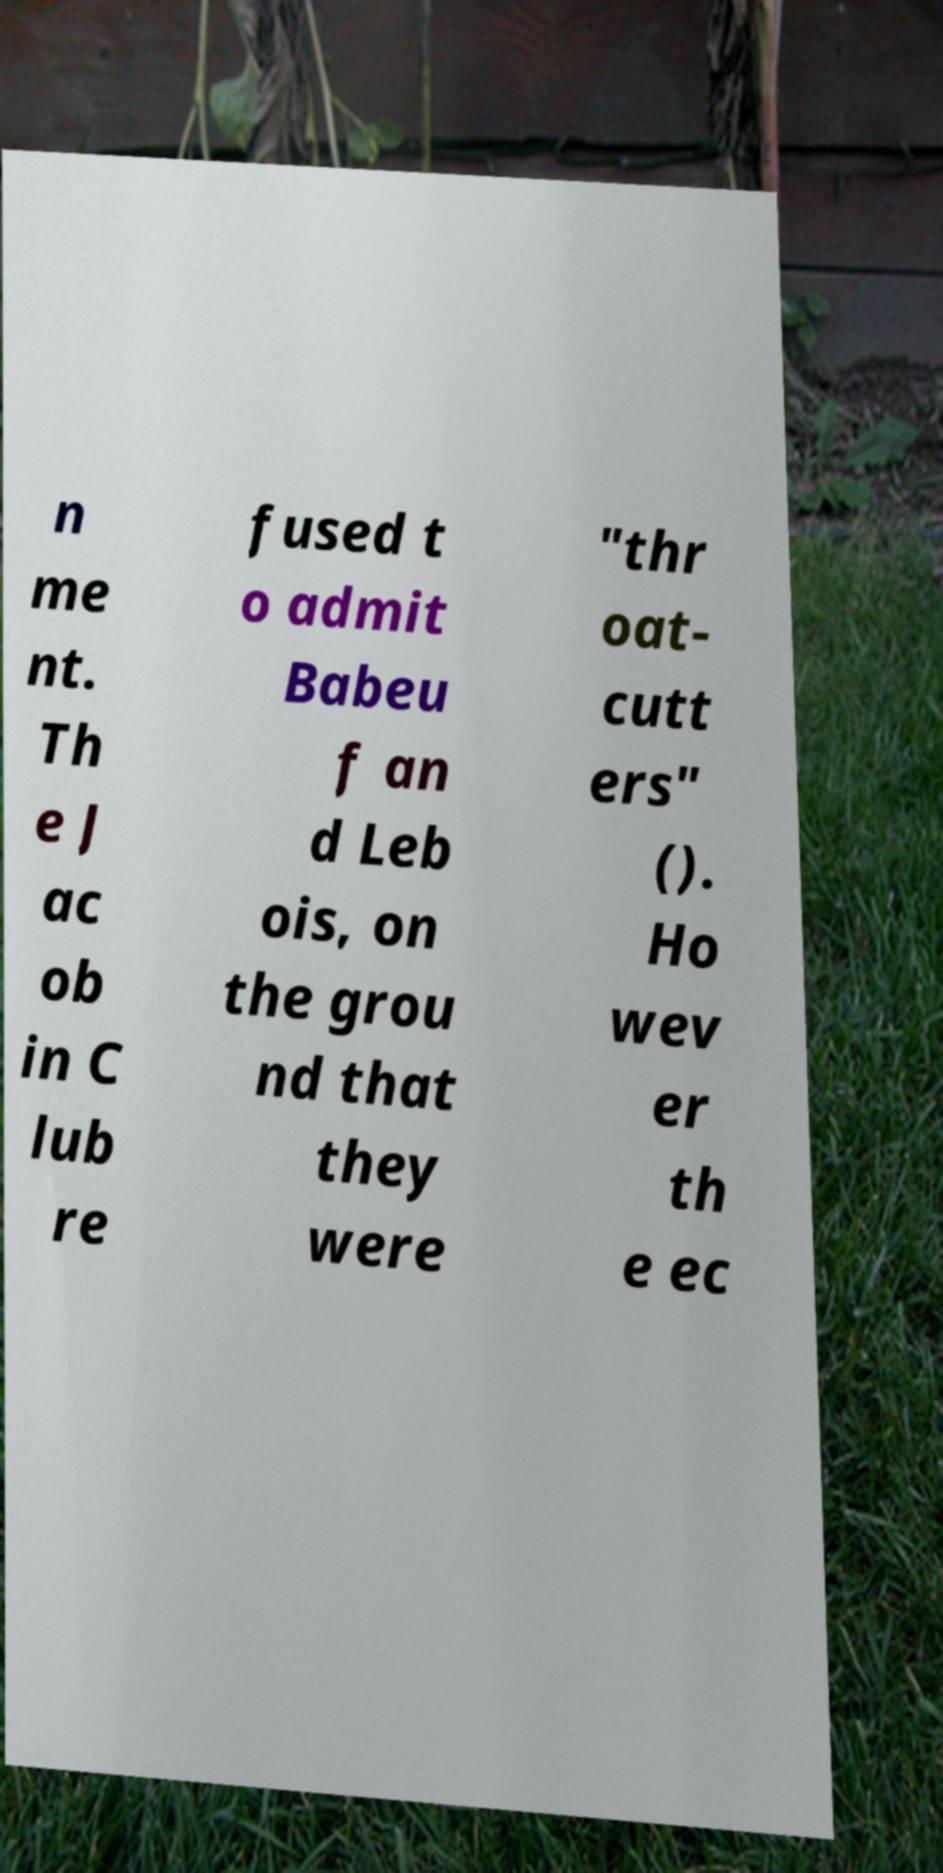For documentation purposes, I need the text within this image transcribed. Could you provide that? n me nt. Th e J ac ob in C lub re fused t o admit Babeu f an d Leb ois, on the grou nd that they were "thr oat- cutt ers" (). Ho wev er th e ec 